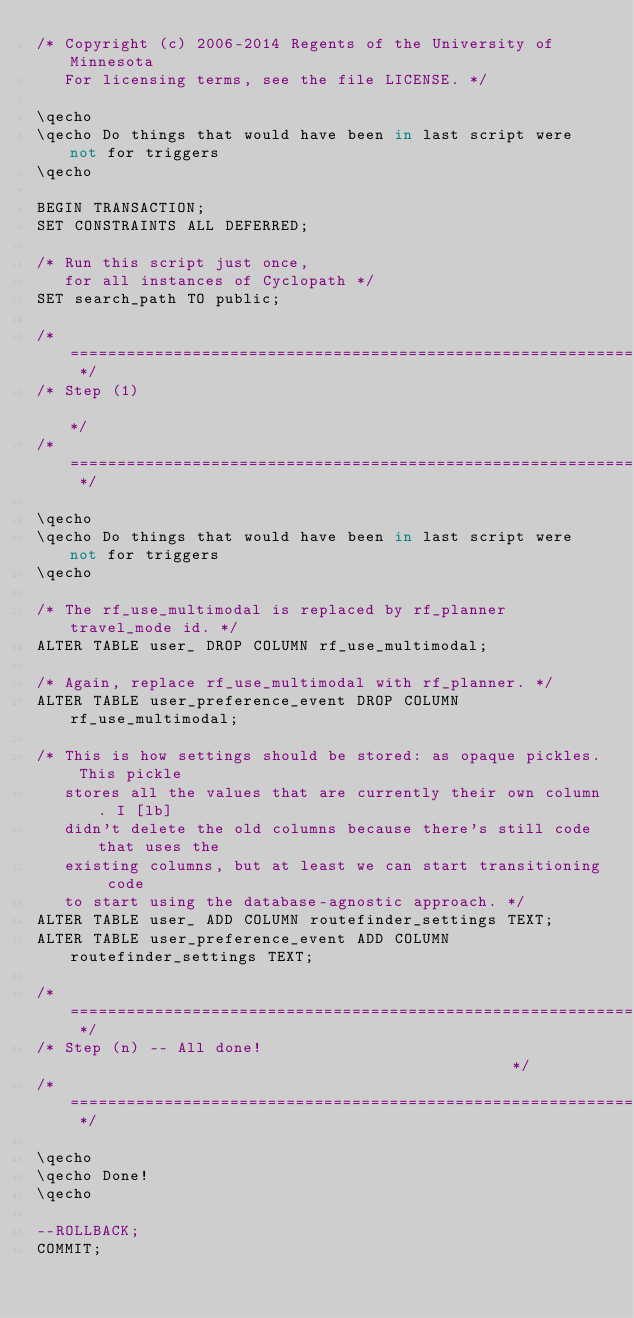Convert code to text. <code><loc_0><loc_0><loc_500><loc_500><_SQL_>/* Copyright (c) 2006-2014 Regents of the University of Minnesota
   For licensing terms, see the file LICENSE. */

\qecho
\qecho Do things that would have been in last script were not for triggers
\qecho

BEGIN TRANSACTION;
SET CONSTRAINTS ALL DEFERRED;

/* Run this script just once, 
   for all instances of Cyclopath */
SET search_path TO public;

/* ==================================================================== */
/* Step (1)                                                             */
/* ==================================================================== */

\qecho
\qecho Do things that would have been in last script were not for triggers
\qecho

/* The rf_use_multimodal is replaced by rf_planner travel_mode id. */
ALTER TABLE user_ DROP COLUMN rf_use_multimodal;

/* Again, replace rf_use_multimodal with rf_planner. */
ALTER TABLE user_preference_event DROP COLUMN rf_use_multimodal;

/* This is how settings should be stored: as opaque pickles. This pickle
   stores all the values that are currently their own column. I [lb]
   didn't delete the old columns because there's still code that uses the
   existing columns, but at least we can start transitioning code
   to start using the database-agnostic approach. */
ALTER TABLE user_ ADD COLUMN routefinder_settings TEXT;
ALTER TABLE user_preference_event ADD COLUMN routefinder_settings TEXT;

/* ==================================================================== */
/* Step (n) -- All done!                                                */
/* ==================================================================== */

\qecho
\qecho Done!
\qecho

--ROLLBACK;
COMMIT;

</code> 